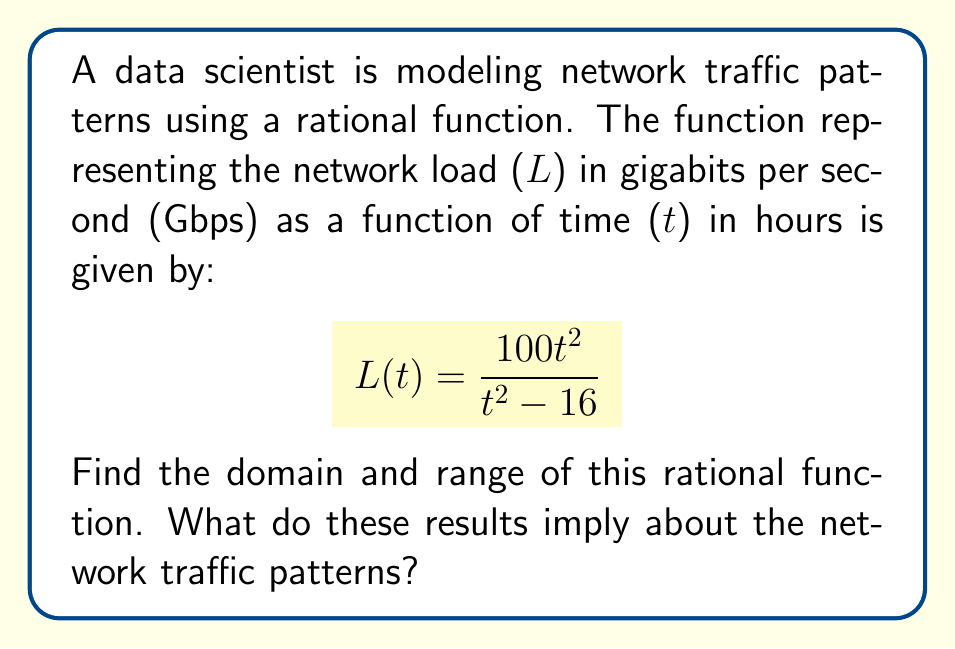Provide a solution to this math problem. To find the domain and range of this rational function, we'll follow these steps:

1. Domain:
   The domain consists of all real numbers except those that make the denominator zero.
   Set the denominator to zero and solve:
   $$t^2 - 16 = 0$$
   $$t^2 = 16$$
   $$t = \pm 4$$
   
   Therefore, the domain is all real numbers except -4 and 4.
   Domain = $\{t \in \mathbb{R} : t \neq -4, t \neq 4\}$

2. Range:
   To find the range, let's analyze the function's behavior:
   
   a) As $t$ approaches $\pm 4$, the denominator approaches 0, causing $L(t)$ to approach $\pm \infty$.
   
   b) As $t$ approaches $\pm \infty$, both numerator and denominator grow at the same rate ($t^2$), so:
      $$\lim_{t \to \pm \infty} L(t) = \lim_{t \to \pm \infty} \frac{100t^2}{t^2 - 16} = 100$$

   c) To find the vertical asymptote, factor the denominator:
      $$L(t) = \frac{100t^2}{(t-4)(t+4)}$$

   d) Find the critical points by setting the derivative to zero:
      $$L'(t) = \frac{200t(t^2-16) - 100t^2(2t)}{(t^2-16)^2} = \frac{200t(-16)}{(t^2-16)^2} = \frac{-3200t}{(t^2-16)^2}$$
      
      Setting $L'(t) = 0$:
      $$-3200t = 0$$
      $$t = 0$$

   e) Evaluate $L(0)$:
      $$L(0) = \frac{100(0)^2}{(0)^2 - 16} = 0$$

   Therefore, the range is all real numbers except the open interval (0, 100).
   Range = $\{L \in \mathbb{R} : L \leq 0 \text{ or } L \geq 100\}$

Implications for network traffic:
1. The network load never reaches values between 0 and 100 Gbps.
2. There are two critical time points (t = -4 and t = 4) where the network load becomes undefined, possibly indicating network outages or resets.
3. The network load approaches but never exceeds 100 Gbps as time increases, suggesting a maximum capacity.
4. At t = 0, the network load is 0 Gbps, which could represent a starting point or minimum load condition.
Answer: Domain: $\{t \in \mathbb{R} : t \neq -4, t \neq 4\}$
Range: $\{L \in \mathbb{R} : L \leq 0 \text{ or } L \geq 100\}$ 